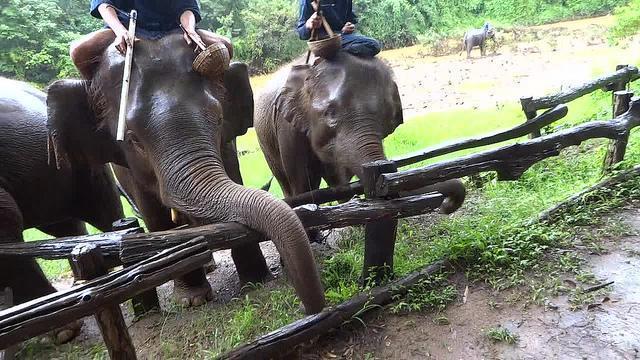How many elephants are visible?
Give a very brief answer. 3. How many people are there?
Give a very brief answer. 2. 